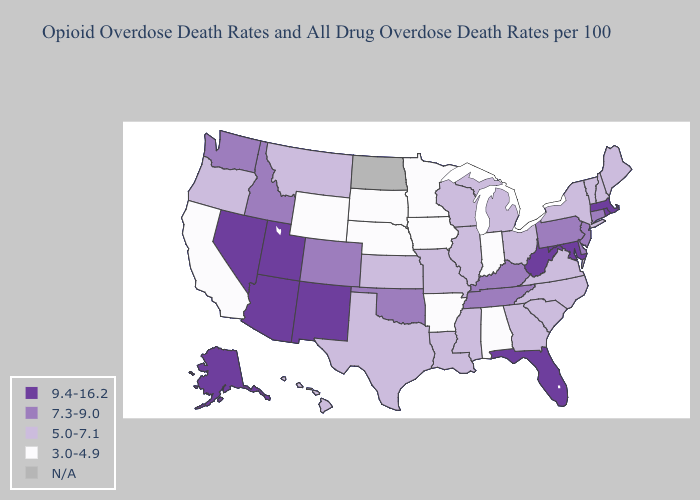Name the states that have a value in the range N/A?
Give a very brief answer. North Dakota. Name the states that have a value in the range 5.0-7.1?
Write a very short answer. Georgia, Hawaii, Illinois, Kansas, Louisiana, Maine, Michigan, Mississippi, Missouri, Montana, New Hampshire, New York, North Carolina, Ohio, Oregon, South Carolina, Texas, Vermont, Virginia, Wisconsin. Does Oklahoma have the lowest value in the South?
Short answer required. No. Name the states that have a value in the range 9.4-16.2?
Concise answer only. Alaska, Arizona, Florida, Maryland, Massachusetts, Nevada, New Mexico, Rhode Island, Utah, West Virginia. Does Virginia have the highest value in the USA?
Be succinct. No. Among the states that border Michigan , which have the highest value?
Give a very brief answer. Ohio, Wisconsin. Name the states that have a value in the range 7.3-9.0?
Answer briefly. Colorado, Connecticut, Delaware, Idaho, Kentucky, New Jersey, Oklahoma, Pennsylvania, Tennessee, Washington. Does Iowa have the lowest value in the USA?
Answer briefly. Yes. Among the states that border Kansas , does Oklahoma have the highest value?
Short answer required. Yes. What is the lowest value in the MidWest?
Keep it brief. 3.0-4.9. Does Tennessee have the highest value in the South?
Write a very short answer. No. Is the legend a continuous bar?
Be succinct. No. What is the value of North Dakota?
Keep it brief. N/A. What is the lowest value in the MidWest?
Keep it brief. 3.0-4.9. What is the lowest value in the USA?
Keep it brief. 3.0-4.9. 